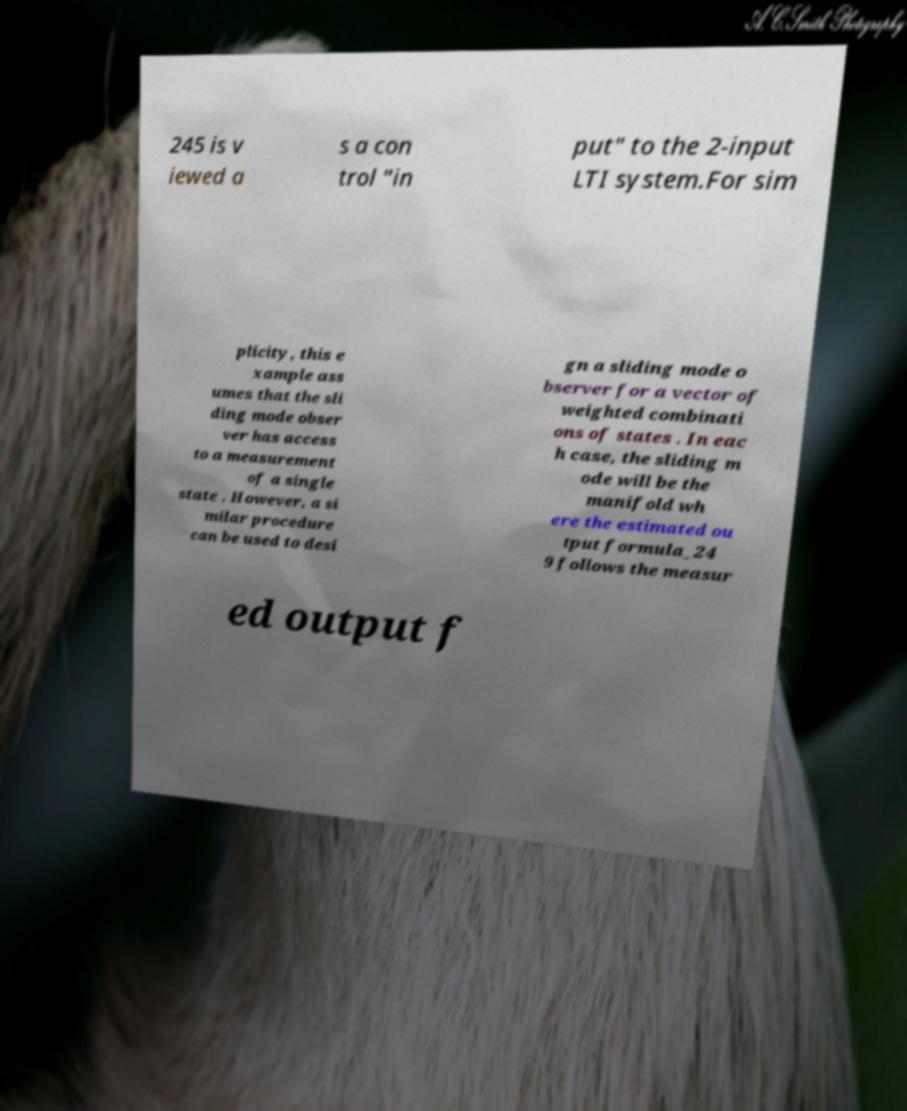Could you assist in decoding the text presented in this image and type it out clearly? 245 is v iewed a s a con trol "in put" to the 2-input LTI system.For sim plicity, this e xample ass umes that the sli ding mode obser ver has access to a measurement of a single state . However, a si milar procedure can be used to desi gn a sliding mode o bserver for a vector of weighted combinati ons of states . In eac h case, the sliding m ode will be the manifold wh ere the estimated ou tput formula_24 9 follows the measur ed output f 